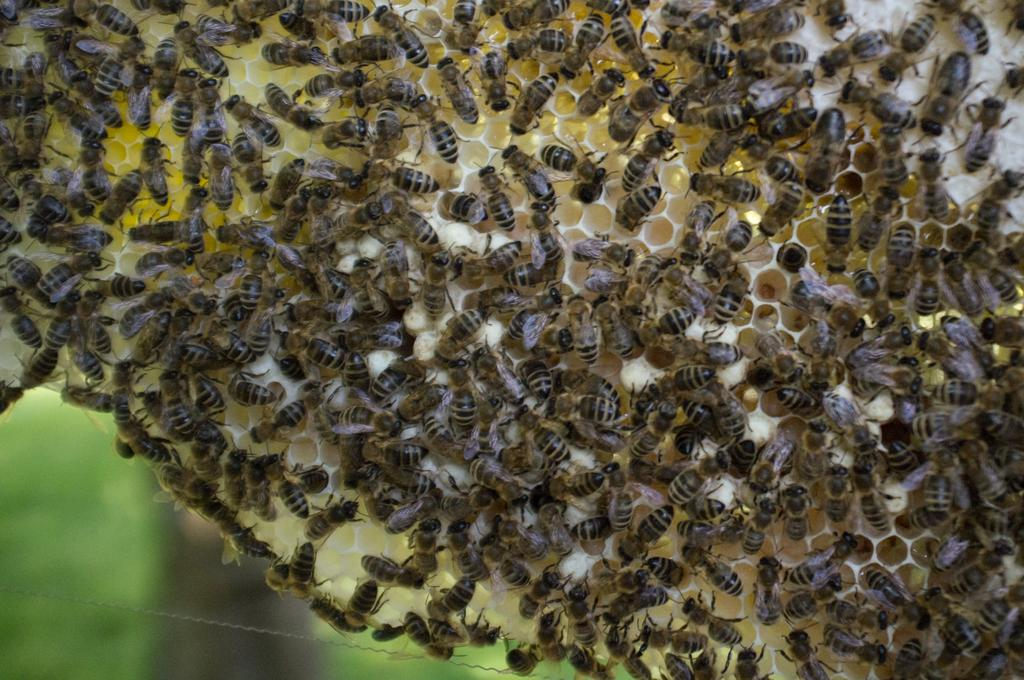What type of insects are present in the image? There are honey bees in the image. What structure can be seen in the image that is associated with honey bees? There is a honeycomb in the image. Can you describe the background of the image? The background of the image is blurred. Where is the scarecrow located in the image? There is no scarecrow present in the image. How many groups of honey bees can be seen in the image? The image only shows honey bees, not groups of honey bees. 